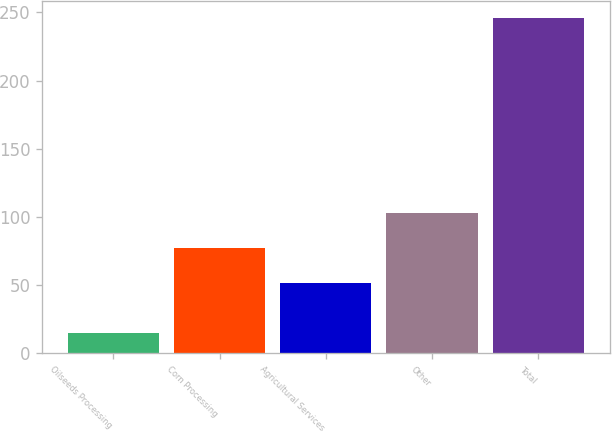Convert chart to OTSL. <chart><loc_0><loc_0><loc_500><loc_500><bar_chart><fcel>Oilseeds Processing<fcel>Corn Processing<fcel>Agricultural Services<fcel>Other<fcel>Total<nl><fcel>15<fcel>77<fcel>51<fcel>103<fcel>246<nl></chart> 